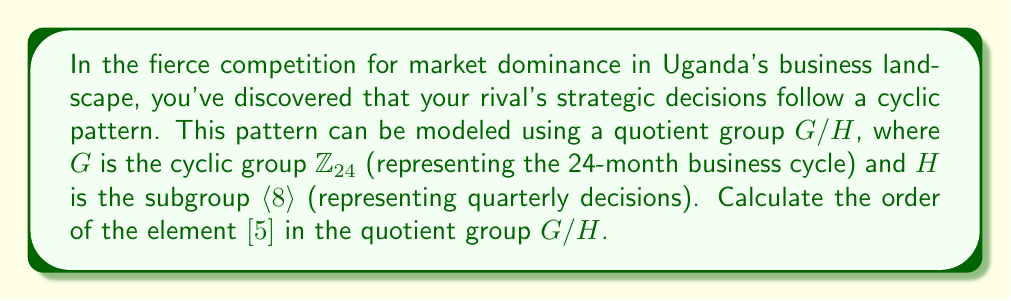Solve this math problem. To solve this problem, we'll follow these steps:

1) First, recall that in a quotient group $G/H$, the order of an element $[a]$ is given by:

   $\text{ord}([a]) = \frac{\text{ord}(a)}{\gcd(\text{ord}(a), |H|)}$

   where $\text{ord}(a)$ is the order of $a$ in $G$, and $|H|$ is the order of the subgroup $H$.

2) In this case, $G = \mathbb{Z}_{24}$ and $H = \langle 8 \rangle$.

3) Let's find $|H|$:
   $H = \langle 8 \rangle = \{0, 8, 16\}$ in $\mathbb{Z}_{24}$
   So, $|H| = 3$

4) Now, we need to find $\text{ord}(5)$ in $\mathbb{Z}_{24}$:
   $5 \cdot 1 = 5 \pmod{24}$
   $5 \cdot 2 = 10 \pmod{24}$
   $5 \cdot 3 = 15 \pmod{24}$
   $5 \cdot 4 = 20 \pmod{24}$
   $5 \cdot 5 = 1 \pmod{24}$
   Therefore, $\text{ord}(5) = 12$ in $\mathbb{Z}_{24}$

5) Now we can apply the formula:

   $\text{ord}([5]) = \frac{\text{ord}(5)}{\gcd(\text{ord}(5), |H|)} = \frac{12}{\gcd(12, 3)} = \frac{12}{3} = 4$

Thus, the order of $[5]$ in the quotient group $G/H$ is 4.
Answer: The order of $[5]$ in the quotient group $G/H$ is 4. 